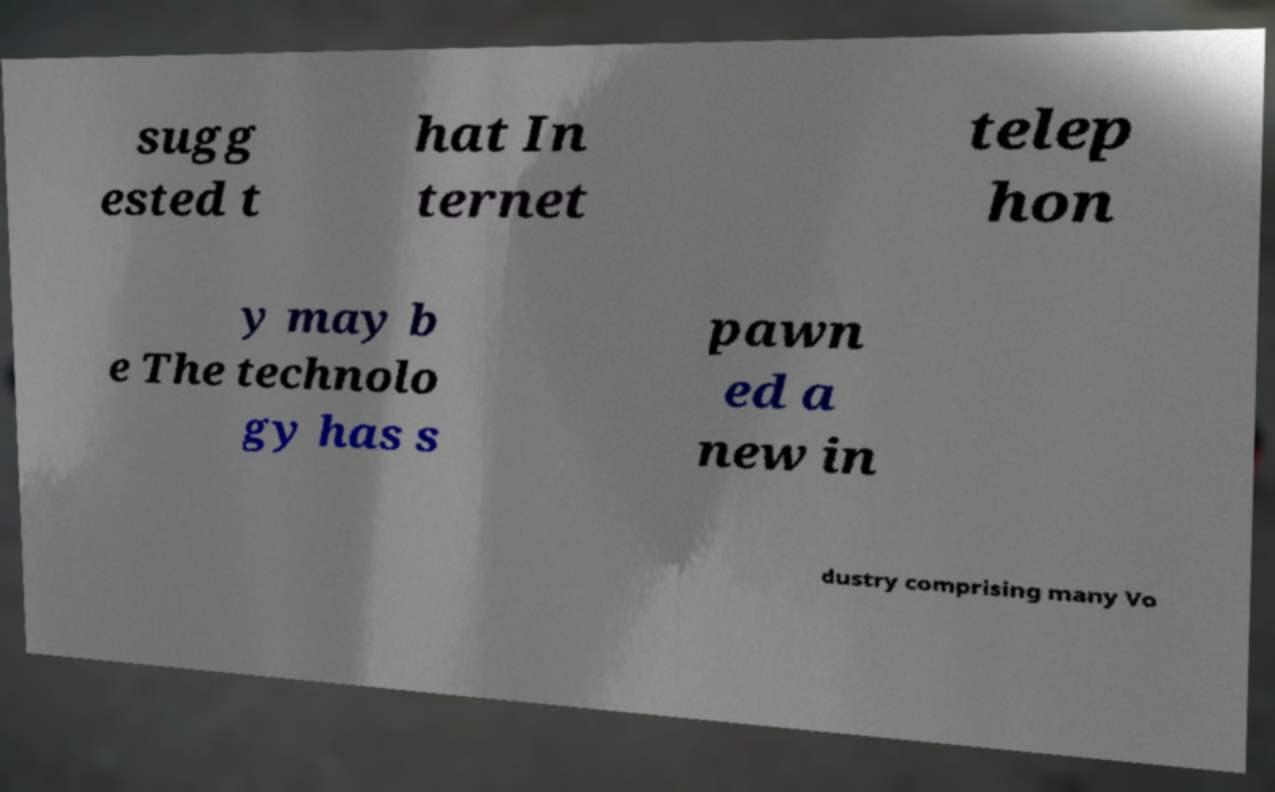There's text embedded in this image that I need extracted. Can you transcribe it verbatim? sugg ested t hat In ternet telep hon y may b e The technolo gy has s pawn ed a new in dustry comprising many Vo 